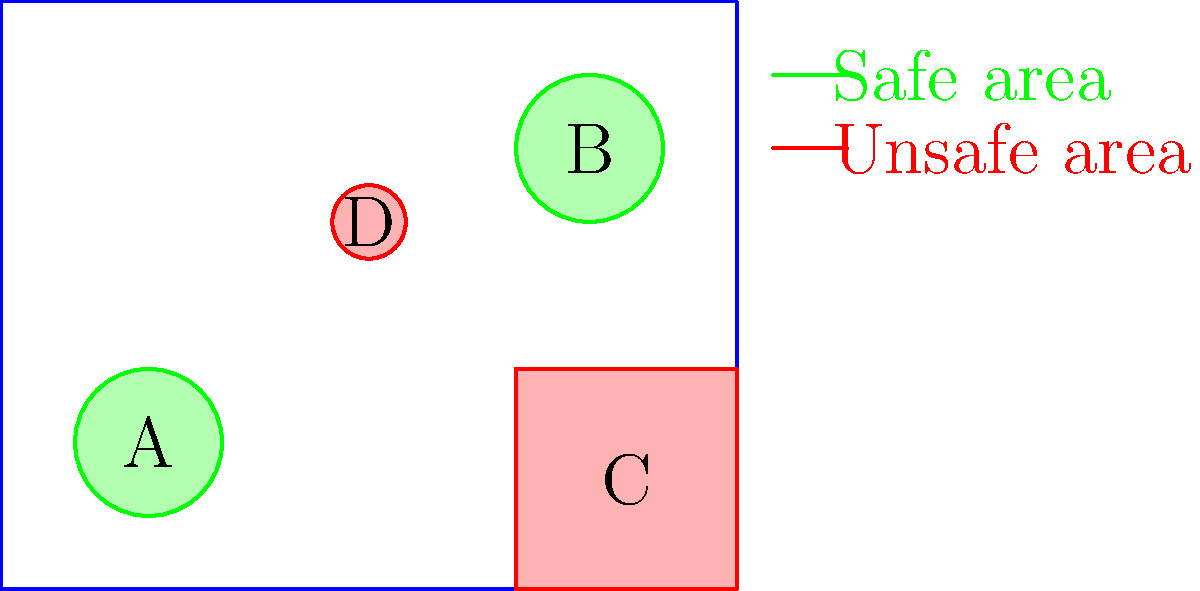In the backyard layout shown, which labeled areas (A, B, C, or D) are safe for a recovering dog to spend time in after surgery? To determine which areas are safe for a recovering dog after surgery, we need to analyze the backyard layout:

1. Area A (2,2): This is a green circle, which represents a safe area. It's away from potential hazards and provides a calm space for the dog to rest.

2. Area B (8,6): This is also a green circle, indicating another safe area. It's elevated in the backyard, possibly providing a good vantage point for the dog while resting.

3. Area C (8.5,1.5): This area is within a red rectangle, which signifies an unsafe area. It could represent a garden with plants toxic to dogs, a area with sharp tools, or a spot with unstable ground.

4. Area D (5,5): This is a small red circle, indicating another unsafe area. It might represent a water feature, a fire pit, or any other specific hazard that could be dangerous for a recovering dog.

Based on this analysis, we can conclude that only areas A and B are safe for the recovering dog. These green areas likely represent flat, calm spaces where the dog can rest without risk of injury or strain during the recovery period.
Answer: A and B 